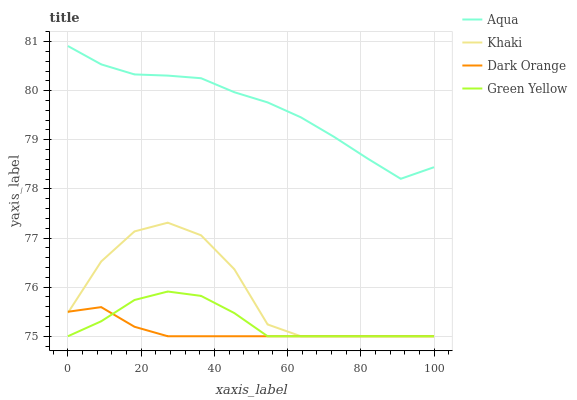Does Dark Orange have the minimum area under the curve?
Answer yes or no. Yes. Does Aqua have the maximum area under the curve?
Answer yes or no. Yes. Does Green Yellow have the minimum area under the curve?
Answer yes or no. No. Does Green Yellow have the maximum area under the curve?
Answer yes or no. No. Is Dark Orange the smoothest?
Answer yes or no. Yes. Is Khaki the roughest?
Answer yes or no. Yes. Is Green Yellow the smoothest?
Answer yes or no. No. Is Green Yellow the roughest?
Answer yes or no. No. Does Dark Orange have the lowest value?
Answer yes or no. Yes. Does Aqua have the lowest value?
Answer yes or no. No. Does Aqua have the highest value?
Answer yes or no. Yes. Does Green Yellow have the highest value?
Answer yes or no. No. Is Khaki less than Aqua?
Answer yes or no. Yes. Is Aqua greater than Dark Orange?
Answer yes or no. Yes. Does Green Yellow intersect Khaki?
Answer yes or no. Yes. Is Green Yellow less than Khaki?
Answer yes or no. No. Is Green Yellow greater than Khaki?
Answer yes or no. No. Does Khaki intersect Aqua?
Answer yes or no. No. 